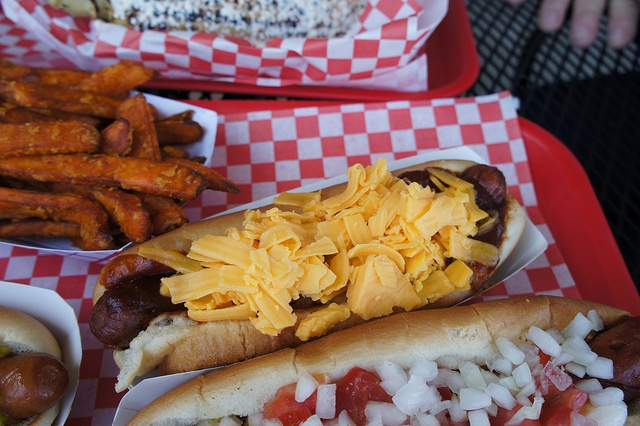Describe the objects in this image and their specific colors. I can see hot dog in purple, tan, olive, orange, and black tones, hot dog in purple, darkgray, maroon, brown, and gray tones, hot dog in purple, maroon, black, and gray tones, and people in purple, gray, and black tones in this image. 